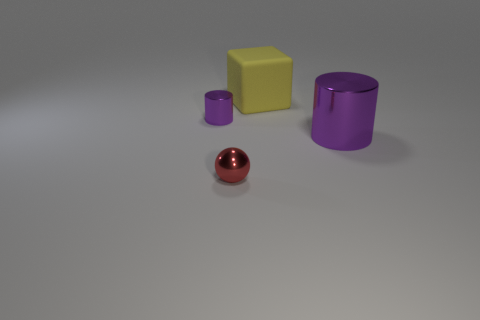Add 1 big cyan metal cylinders. How many objects exist? 5 Subtract all cubes. How many objects are left? 3 Subtract 0 brown blocks. How many objects are left? 4 Subtract all tiny red metallic balls. Subtract all small shiny cylinders. How many objects are left? 2 Add 1 blocks. How many blocks are left? 2 Add 3 tiny metal things. How many tiny metal things exist? 5 